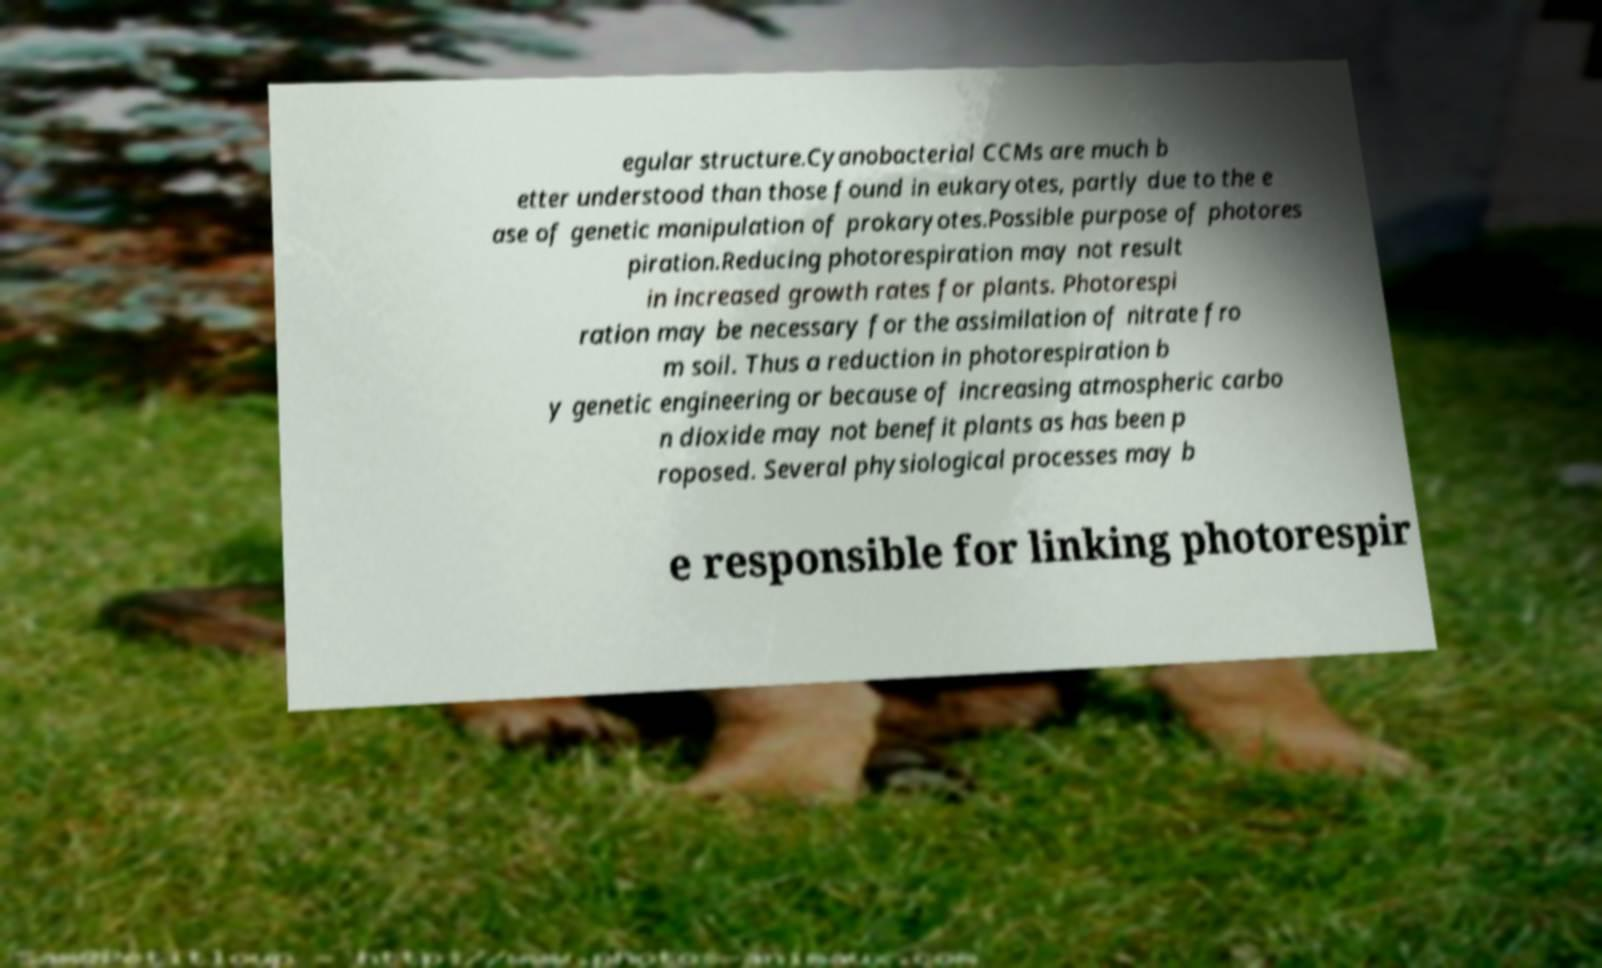There's text embedded in this image that I need extracted. Can you transcribe it verbatim? egular structure.Cyanobacterial CCMs are much b etter understood than those found in eukaryotes, partly due to the e ase of genetic manipulation of prokaryotes.Possible purpose of photores piration.Reducing photorespiration may not result in increased growth rates for plants. Photorespi ration may be necessary for the assimilation of nitrate fro m soil. Thus a reduction in photorespiration b y genetic engineering or because of increasing atmospheric carbo n dioxide may not benefit plants as has been p roposed. Several physiological processes may b e responsible for linking photorespir 